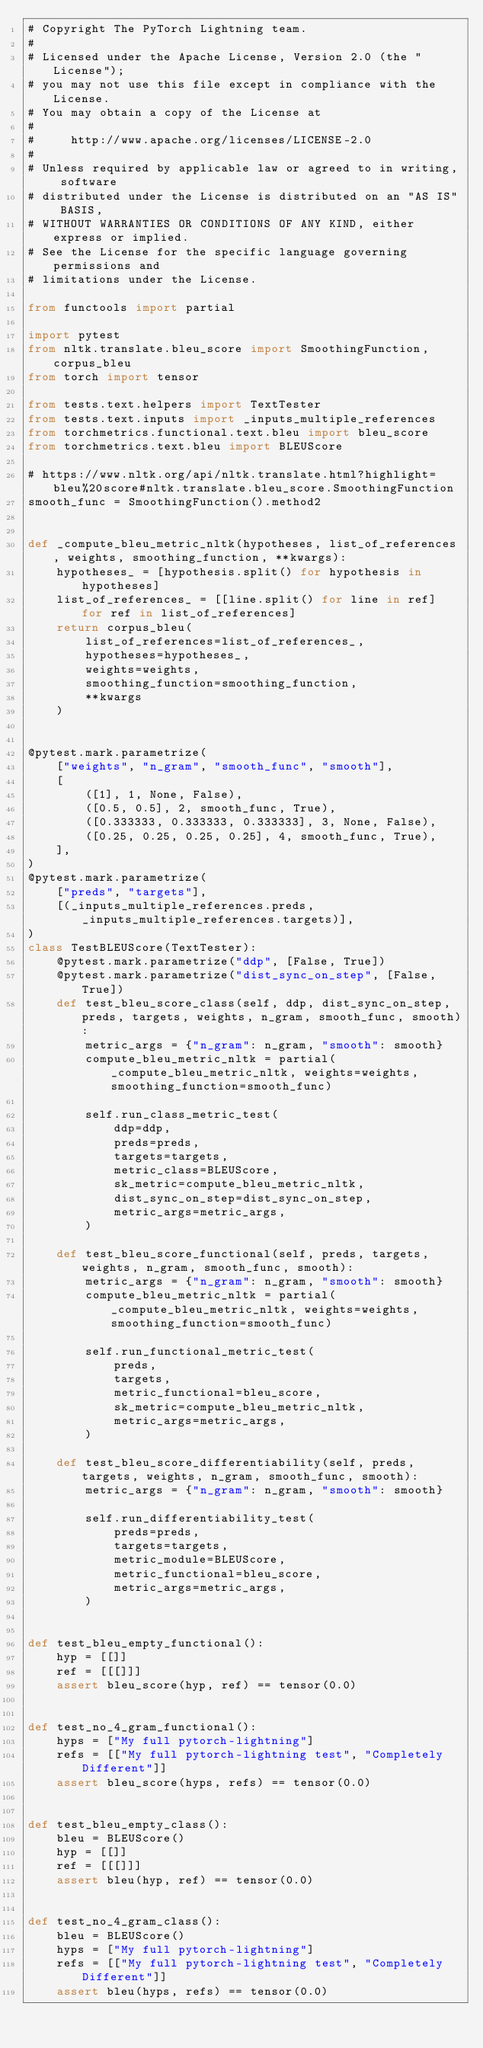<code> <loc_0><loc_0><loc_500><loc_500><_Python_># Copyright The PyTorch Lightning team.
#
# Licensed under the Apache License, Version 2.0 (the "License");
# you may not use this file except in compliance with the License.
# You may obtain a copy of the License at
#
#     http://www.apache.org/licenses/LICENSE-2.0
#
# Unless required by applicable law or agreed to in writing, software
# distributed under the License is distributed on an "AS IS" BASIS,
# WITHOUT WARRANTIES OR CONDITIONS OF ANY KIND, either express or implied.
# See the License for the specific language governing permissions and
# limitations under the License.

from functools import partial

import pytest
from nltk.translate.bleu_score import SmoothingFunction, corpus_bleu
from torch import tensor

from tests.text.helpers import TextTester
from tests.text.inputs import _inputs_multiple_references
from torchmetrics.functional.text.bleu import bleu_score
from torchmetrics.text.bleu import BLEUScore

# https://www.nltk.org/api/nltk.translate.html?highlight=bleu%20score#nltk.translate.bleu_score.SmoothingFunction
smooth_func = SmoothingFunction().method2


def _compute_bleu_metric_nltk(hypotheses, list_of_references, weights, smoothing_function, **kwargs):
    hypotheses_ = [hypothesis.split() for hypothesis in hypotheses]
    list_of_references_ = [[line.split() for line in ref] for ref in list_of_references]
    return corpus_bleu(
        list_of_references=list_of_references_,
        hypotheses=hypotheses_,
        weights=weights,
        smoothing_function=smoothing_function,
        **kwargs
    )


@pytest.mark.parametrize(
    ["weights", "n_gram", "smooth_func", "smooth"],
    [
        ([1], 1, None, False),
        ([0.5, 0.5], 2, smooth_func, True),
        ([0.333333, 0.333333, 0.333333], 3, None, False),
        ([0.25, 0.25, 0.25, 0.25], 4, smooth_func, True),
    ],
)
@pytest.mark.parametrize(
    ["preds", "targets"],
    [(_inputs_multiple_references.preds, _inputs_multiple_references.targets)],
)
class TestBLEUScore(TextTester):
    @pytest.mark.parametrize("ddp", [False, True])
    @pytest.mark.parametrize("dist_sync_on_step", [False, True])
    def test_bleu_score_class(self, ddp, dist_sync_on_step, preds, targets, weights, n_gram, smooth_func, smooth):
        metric_args = {"n_gram": n_gram, "smooth": smooth}
        compute_bleu_metric_nltk = partial(_compute_bleu_metric_nltk, weights=weights, smoothing_function=smooth_func)

        self.run_class_metric_test(
            ddp=ddp,
            preds=preds,
            targets=targets,
            metric_class=BLEUScore,
            sk_metric=compute_bleu_metric_nltk,
            dist_sync_on_step=dist_sync_on_step,
            metric_args=metric_args,
        )

    def test_bleu_score_functional(self, preds, targets, weights, n_gram, smooth_func, smooth):
        metric_args = {"n_gram": n_gram, "smooth": smooth}
        compute_bleu_metric_nltk = partial(_compute_bleu_metric_nltk, weights=weights, smoothing_function=smooth_func)

        self.run_functional_metric_test(
            preds,
            targets,
            metric_functional=bleu_score,
            sk_metric=compute_bleu_metric_nltk,
            metric_args=metric_args,
        )

    def test_bleu_score_differentiability(self, preds, targets, weights, n_gram, smooth_func, smooth):
        metric_args = {"n_gram": n_gram, "smooth": smooth}

        self.run_differentiability_test(
            preds=preds,
            targets=targets,
            metric_module=BLEUScore,
            metric_functional=bleu_score,
            metric_args=metric_args,
        )


def test_bleu_empty_functional():
    hyp = [[]]
    ref = [[[]]]
    assert bleu_score(hyp, ref) == tensor(0.0)


def test_no_4_gram_functional():
    hyps = ["My full pytorch-lightning"]
    refs = [["My full pytorch-lightning test", "Completely Different"]]
    assert bleu_score(hyps, refs) == tensor(0.0)


def test_bleu_empty_class():
    bleu = BLEUScore()
    hyp = [[]]
    ref = [[[]]]
    assert bleu(hyp, ref) == tensor(0.0)


def test_no_4_gram_class():
    bleu = BLEUScore()
    hyps = ["My full pytorch-lightning"]
    refs = [["My full pytorch-lightning test", "Completely Different"]]
    assert bleu(hyps, refs) == tensor(0.0)
</code> 